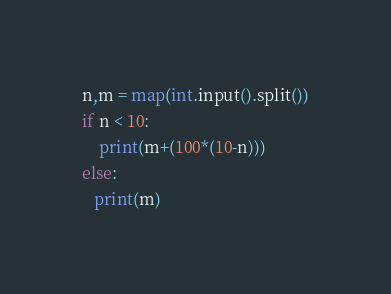<code> <loc_0><loc_0><loc_500><loc_500><_Python_>
n,m = map(int.input().split())
if n < 10:
    print(m+(100*(10-n)))
else:
   print(m)</code> 